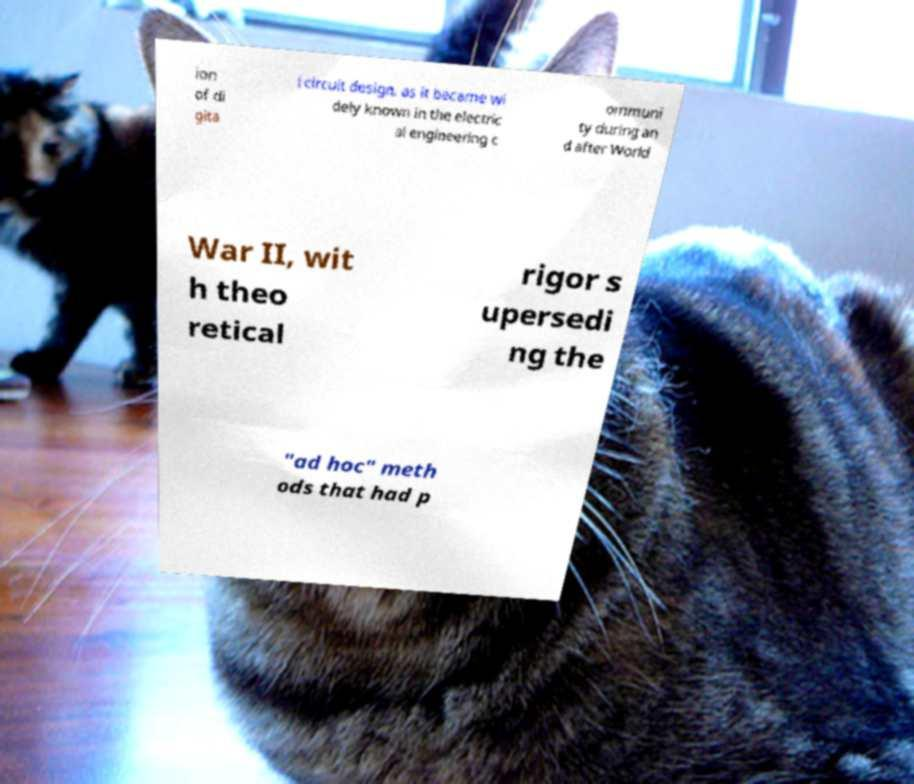I need the written content from this picture converted into text. Can you do that? ion of di gita l circuit design, as it became wi dely known in the electric al engineering c ommuni ty during an d after World War II, wit h theo retical rigor s upersedi ng the "ad hoc" meth ods that had p 